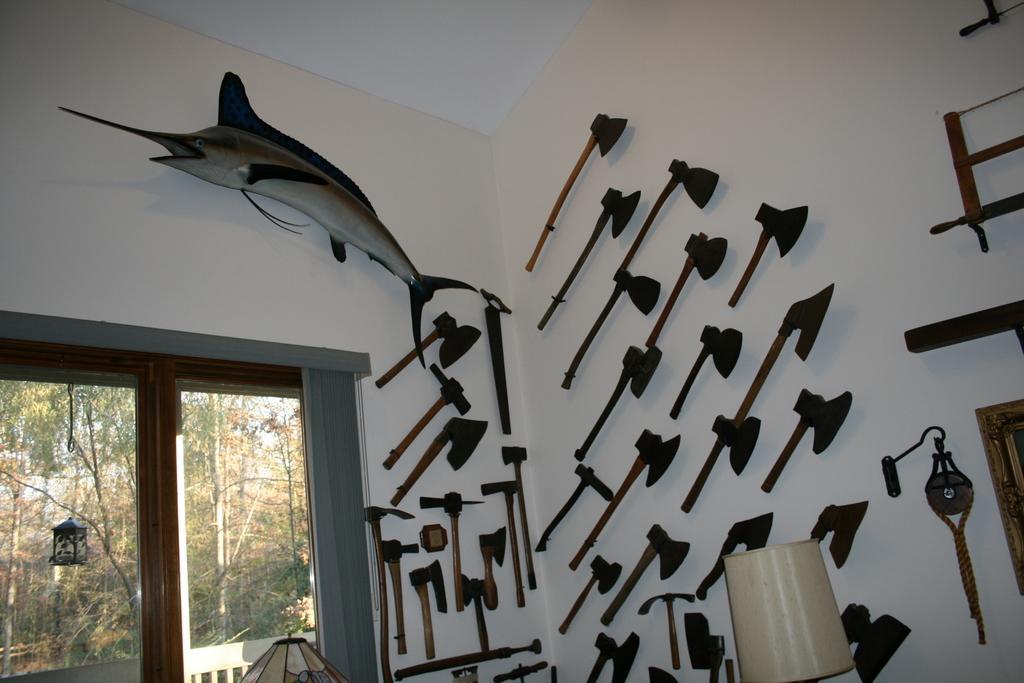Please provide a concise description of this image. In this image, we can see axes and weapons on the wall. Here we can see fish shaped object and few things in the image. On the left side bottom, we can see glass window. Through the glass we can see lantern, trees and railing. 